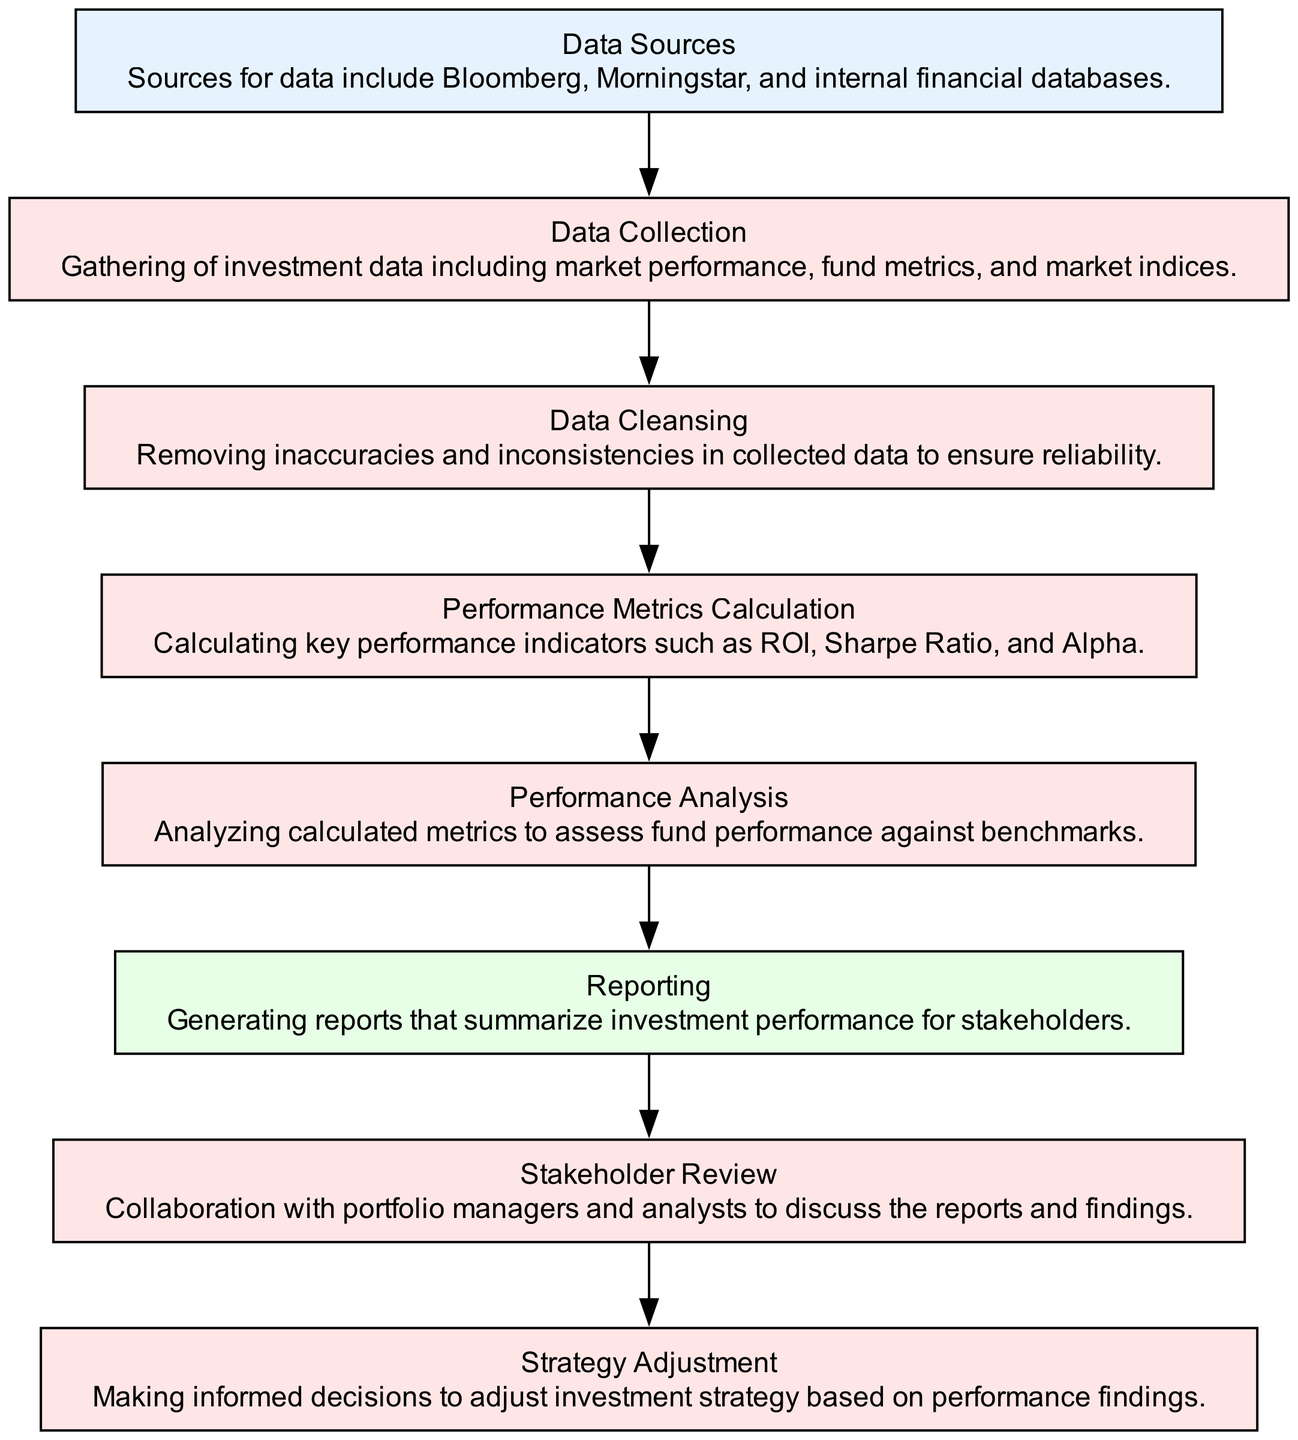What is the first process in the flow? The first process in the flow is "Data Collection." It is indicated as the first node that follows the "Data Sources" input, which means gathering data is the first step in the process.
Answer: Data Collection How many processes are involved in the evaluation flow? There are six processes in the evaluation flow: Data Collection, Data Cleansing, Performance Metrics Calculation, Performance Analysis, Stakeholder Review, and Strategy Adjustment. Each of these is represented as a process node in the diagram.
Answer: Six processes What is the output of the Performance Analysis step? The output of the Performance Analysis step is the "Reporting" node. This indicates that after analyzing the performance metrics, the next step is to generate reports based on these analyses.
Answer: Reporting Which node receives input from "Data Sources"? The node that receives input from "Data Sources" is "Data Collection." This relationship is represented by an arrow connecting the two nodes, indicating that data collection starts from the sources.
Answer: Data Collection What comes after Reporting in the flow? The step that comes after Reporting in the flow is "Stakeholder Review." This shows that after generating performance reports, the findings are reviewed collaboratively with stakeholders.
Answer: Stakeholder Review What is the last process in the flowchart? The last process in the flowchart is "Strategy Adjustment." It signifies that after reviewing performance with stakeholders, decisions are made regarding potential adjustments to the investment strategy.
Answer: Strategy Adjustment What do we eliminate during the Data Cleansing step? During the Data Cleansing step, we eliminate inaccuracies and inconsistencies in the collected data to ensure the reliability of the information used in subsequent evaluations.
Answer: Inaccuracies and inconsistencies Which data sources are mentioned for the evaluation? The data sources mentioned for the evaluation are Bloomberg, Morningstar, and internal financial databases, which are all listed in the "Data Sources" node.
Answer: Bloomberg, Morningstar, internal financial databases What happens after the Strategy Adjustment process? According to the flow, there is no subsequent process after the "Strategy Adjustment" node. It is the final step in the performance evaluation process.
Answer: None 